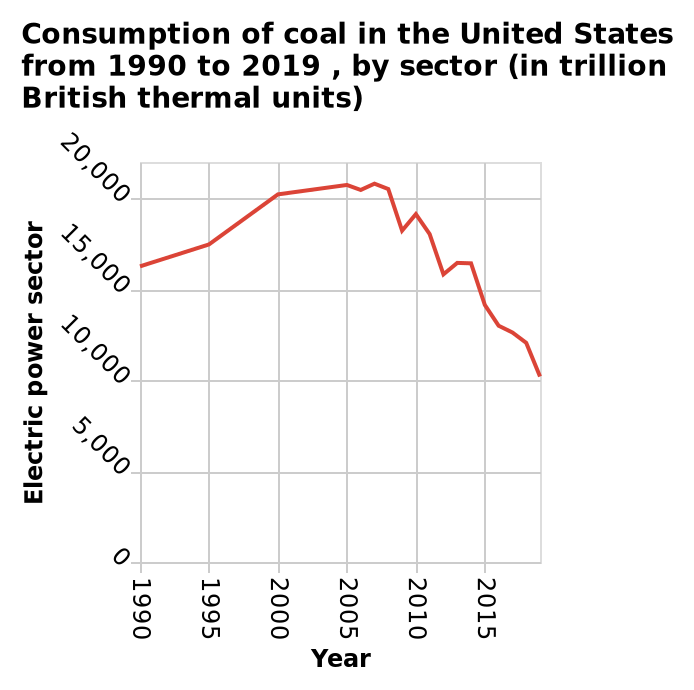<image>
What was the percentage decrease in coal usage from 2005 to 2020? The coal usage decreased by 50% from 2005 to 2020. What is the time period covered in the line diagram? The line diagram represents the consumption of coal in the United States from 1990 to 2019. How does the amount of coal used in 2020 compare to that used in 2005?  The amount of coal used in 2020 is half of that used in 2005. What has been the trend in coal usage since 2005?  Since 2005, the trend in coal usage has been a reduction. 